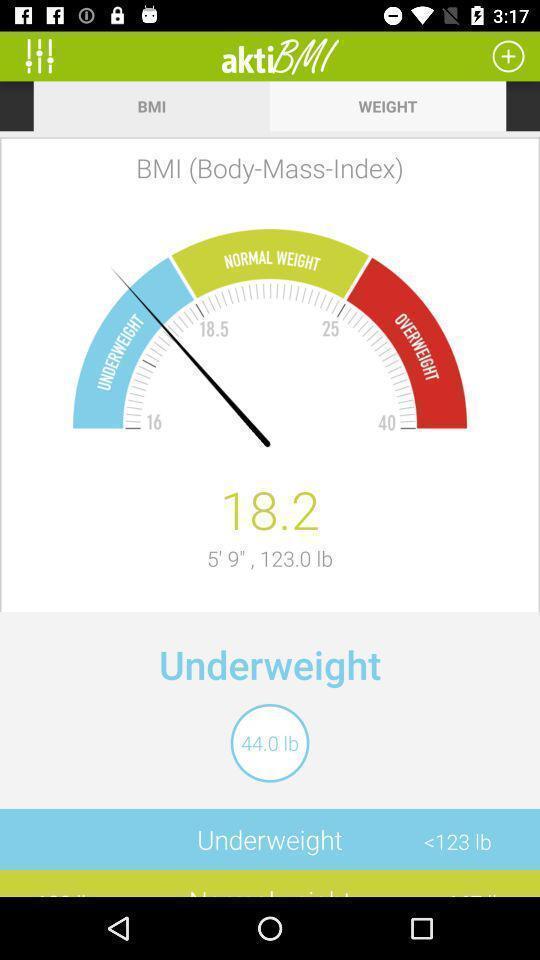Please provide a description for this image. Screen displaying bmi on weight management app. 